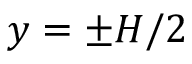<formula> <loc_0><loc_0><loc_500><loc_500>y = \pm H / 2</formula> 